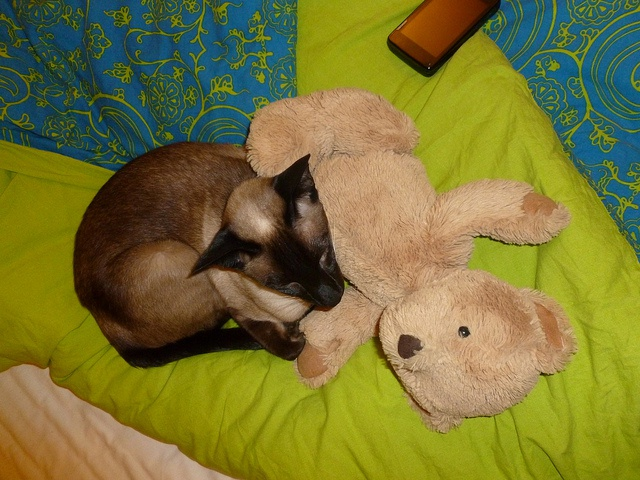Describe the objects in this image and their specific colors. I can see bed in olive, tan, black, and blue tones, teddy bear in darkblue, tan, and gray tones, cat in darkblue, black, maroon, and gray tones, and cell phone in darkblue, maroon, black, and brown tones in this image. 